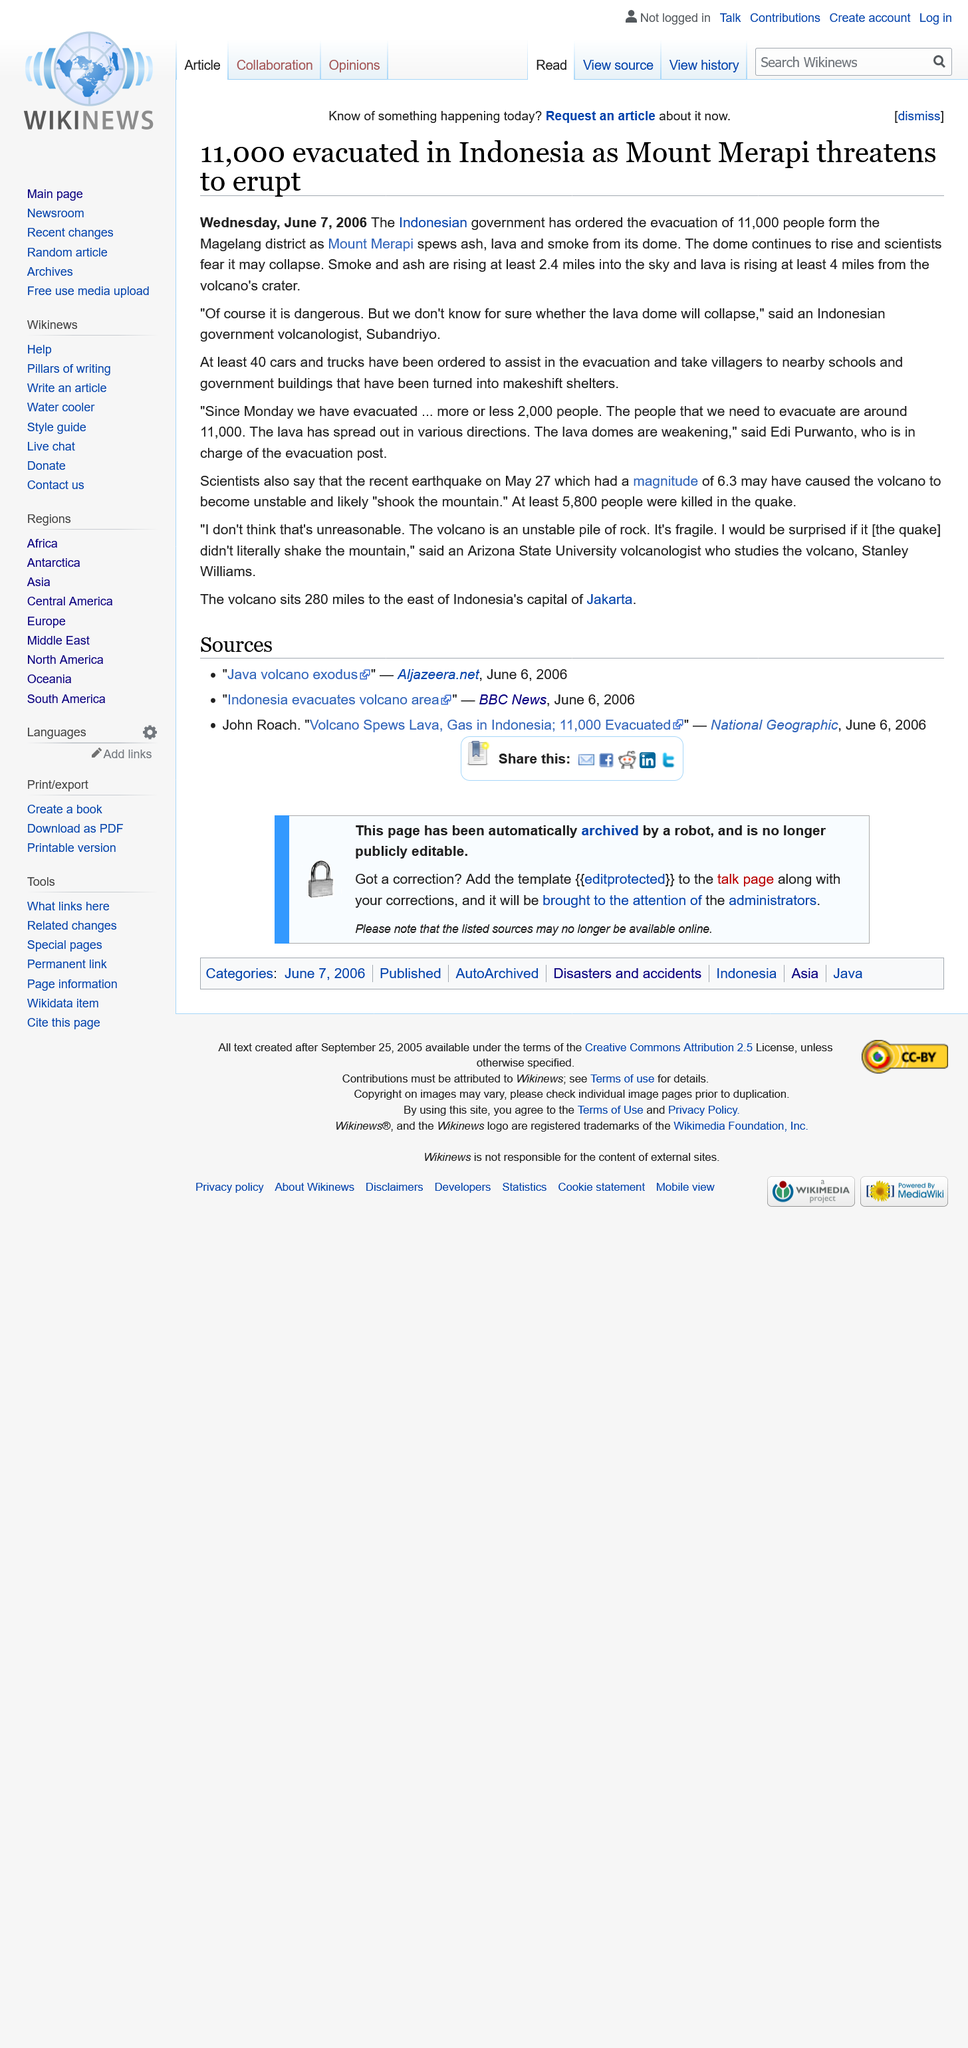Point out several critical features in this image. Mount Merapi was threatening to erupt, posing a potential danger to those in the surrounding area. A total of 11,000 people were evacuated. The eruption took place in Indonesia. 